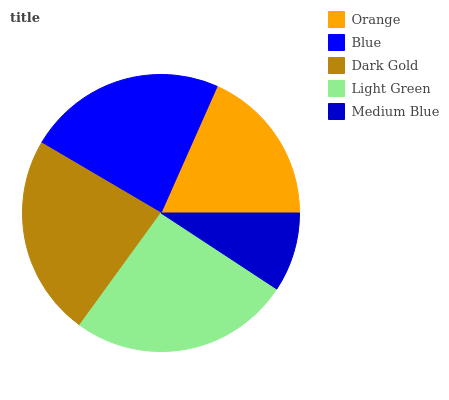Is Medium Blue the minimum?
Answer yes or no. Yes. Is Light Green the maximum?
Answer yes or no. Yes. Is Blue the minimum?
Answer yes or no. No. Is Blue the maximum?
Answer yes or no. No. Is Blue greater than Orange?
Answer yes or no. Yes. Is Orange less than Blue?
Answer yes or no. Yes. Is Orange greater than Blue?
Answer yes or no. No. Is Blue less than Orange?
Answer yes or no. No. Is Blue the high median?
Answer yes or no. Yes. Is Blue the low median?
Answer yes or no. Yes. Is Medium Blue the high median?
Answer yes or no. No. Is Dark Gold the low median?
Answer yes or no. No. 